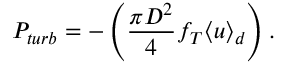Convert formula to latex. <formula><loc_0><loc_0><loc_500><loc_500>P _ { t u r b } = - \left ( \frac { \pi D ^ { 2 } } { 4 } f _ { T } \langle u \rangle _ { d } \right ) .</formula> 